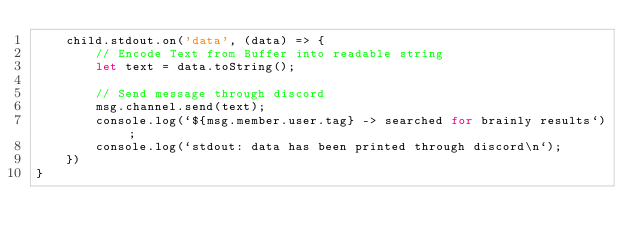<code> <loc_0><loc_0><loc_500><loc_500><_JavaScript_>    child.stdout.on('data', (data) => {
        // Encode Text from Buffer into readable string
        let text = data.toString();

        // Send message through discord
        msg.channel.send(text);
        console.log(`${msg.member.user.tag} -> searched for brainly results`);
        console.log(`stdout: data has been printed through discord\n`);
    })
}
</code> 